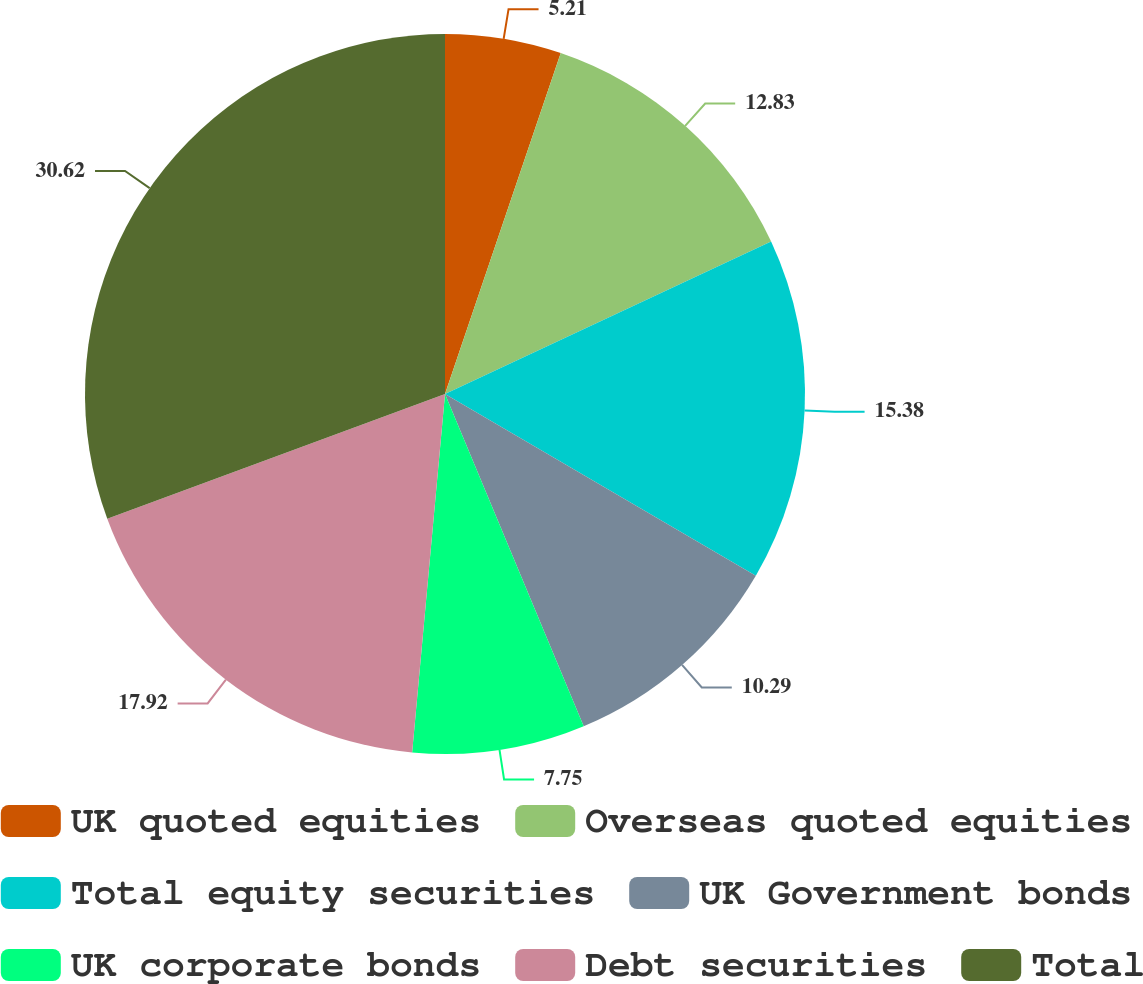Convert chart. <chart><loc_0><loc_0><loc_500><loc_500><pie_chart><fcel>UK quoted equities<fcel>Overseas quoted equities<fcel>Total equity securities<fcel>UK Government bonds<fcel>UK corporate bonds<fcel>Debt securities<fcel>Total<nl><fcel>5.21%<fcel>12.83%<fcel>15.38%<fcel>10.29%<fcel>7.75%<fcel>17.92%<fcel>30.63%<nl></chart> 